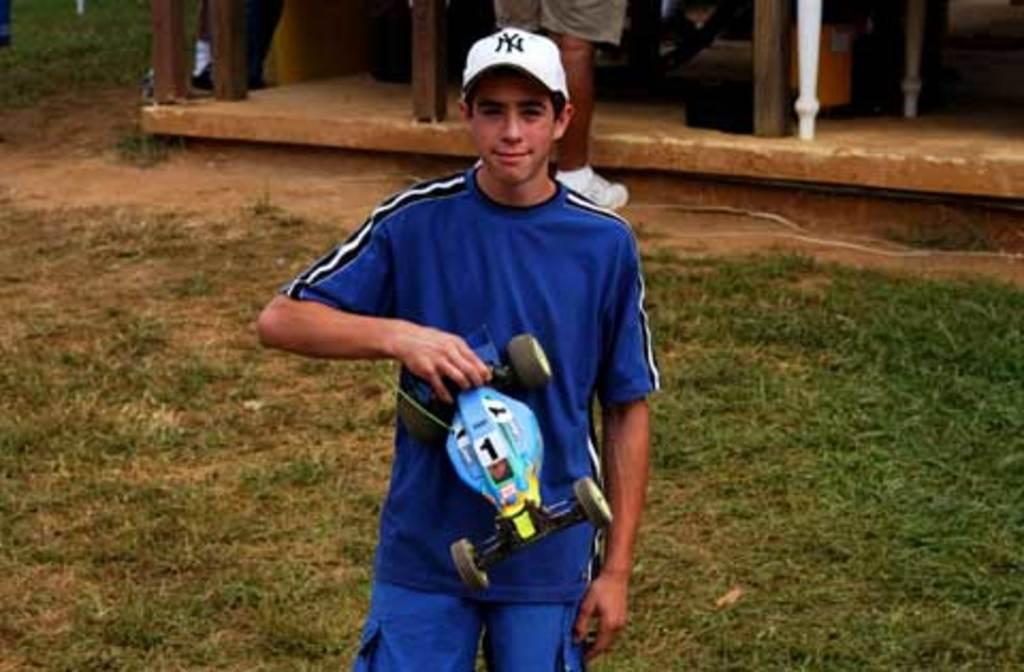What is the man in the image holding? The man is holding a toy car in his hand. What type of surface can be seen in the image? There is grass visible in the image. Can you describe the background of the image? In the background of the image, there are legs of two persons and wooden sticks. What type of vegetable is the man eating in the image? There is no vegetable present in the image; the man is holding a toy car. What is the reaction of the two persons in the background when they see the man holding the toy car? There is no information about the reaction of the two persons in the background, as their faces are not visible in the image. 